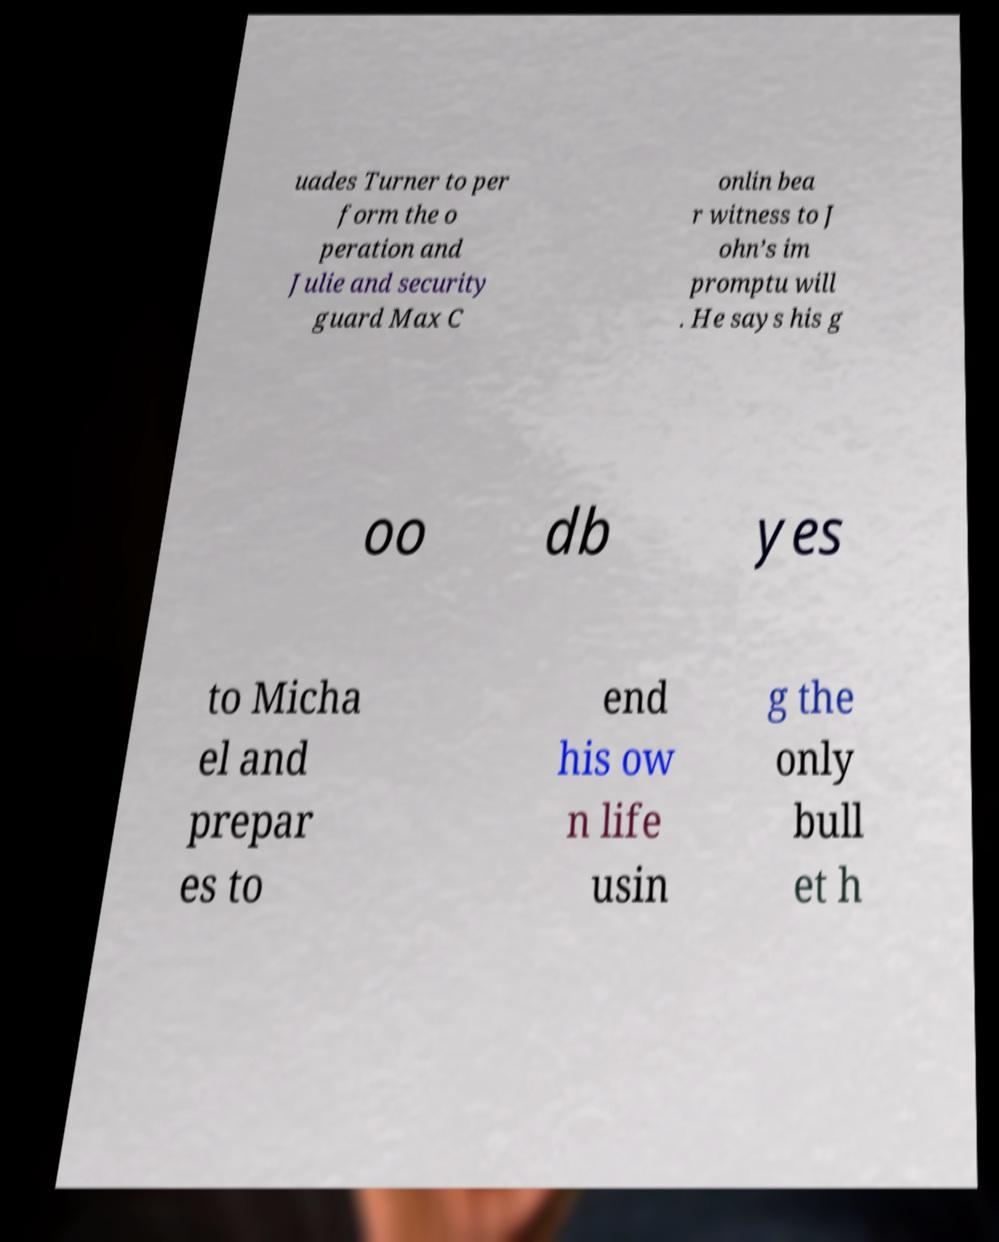I need the written content from this picture converted into text. Can you do that? uades Turner to per form the o peration and Julie and security guard Max C onlin bea r witness to J ohn’s im promptu will . He says his g oo db yes to Micha el and prepar es to end his ow n life usin g the only bull et h 